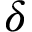Convert formula to latex. <formula><loc_0><loc_0><loc_500><loc_500>\delta</formula> 